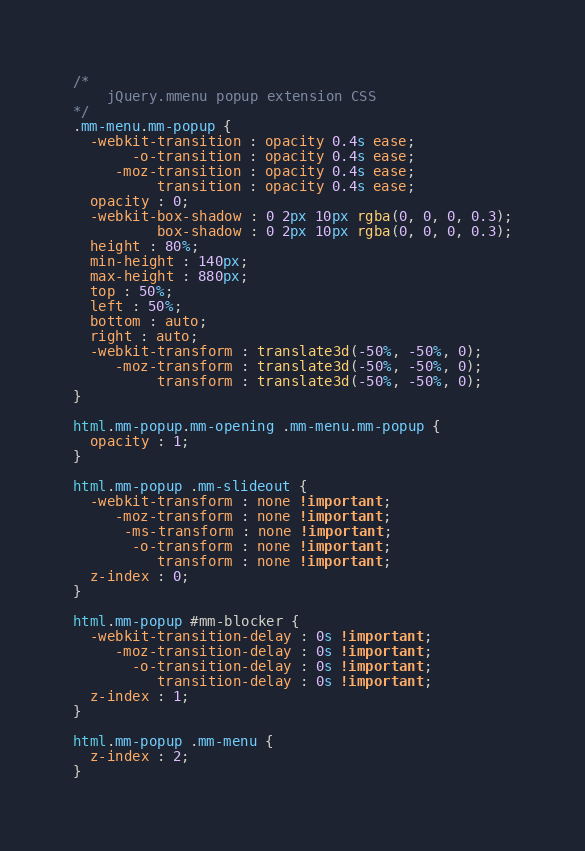Convert code to text. <code><loc_0><loc_0><loc_500><loc_500><_CSS_>/*
	jQuery.mmenu popup extension CSS
*/
.mm-menu.mm-popup {
  -webkit-transition : opacity 0.4s ease;
       -o-transition : opacity 0.4s ease;
     -moz-transition : opacity 0.4s ease;
          transition : opacity 0.4s ease;
  opacity : 0;
  -webkit-box-shadow : 0 2px 10px rgba(0, 0, 0, 0.3);
          box-shadow : 0 2px 10px rgba(0, 0, 0, 0.3);
  height : 80%;
  min-height : 140px;
  max-height : 880px;
  top : 50%;
  left : 50%;
  bottom : auto;
  right : auto;
  -webkit-transform : translate3d(-50%, -50%, 0);
     -moz-transform : translate3d(-50%, -50%, 0);
          transform : translate3d(-50%, -50%, 0);
}

html.mm-popup.mm-opening .mm-menu.mm-popup {
  opacity : 1;
}

html.mm-popup .mm-slideout {
  -webkit-transform : none !important;
     -moz-transform : none !important;
      -ms-transform : none !important;
       -o-transform : none !important;
          transform : none !important;
  z-index : 0;
}

html.mm-popup #mm-blocker {
  -webkit-transition-delay : 0s !important;
     -moz-transition-delay : 0s !important;
       -o-transition-delay : 0s !important;
          transition-delay : 0s !important;
  z-index : 1;
}

html.mm-popup .mm-menu {
  z-index : 2;
}</code> 